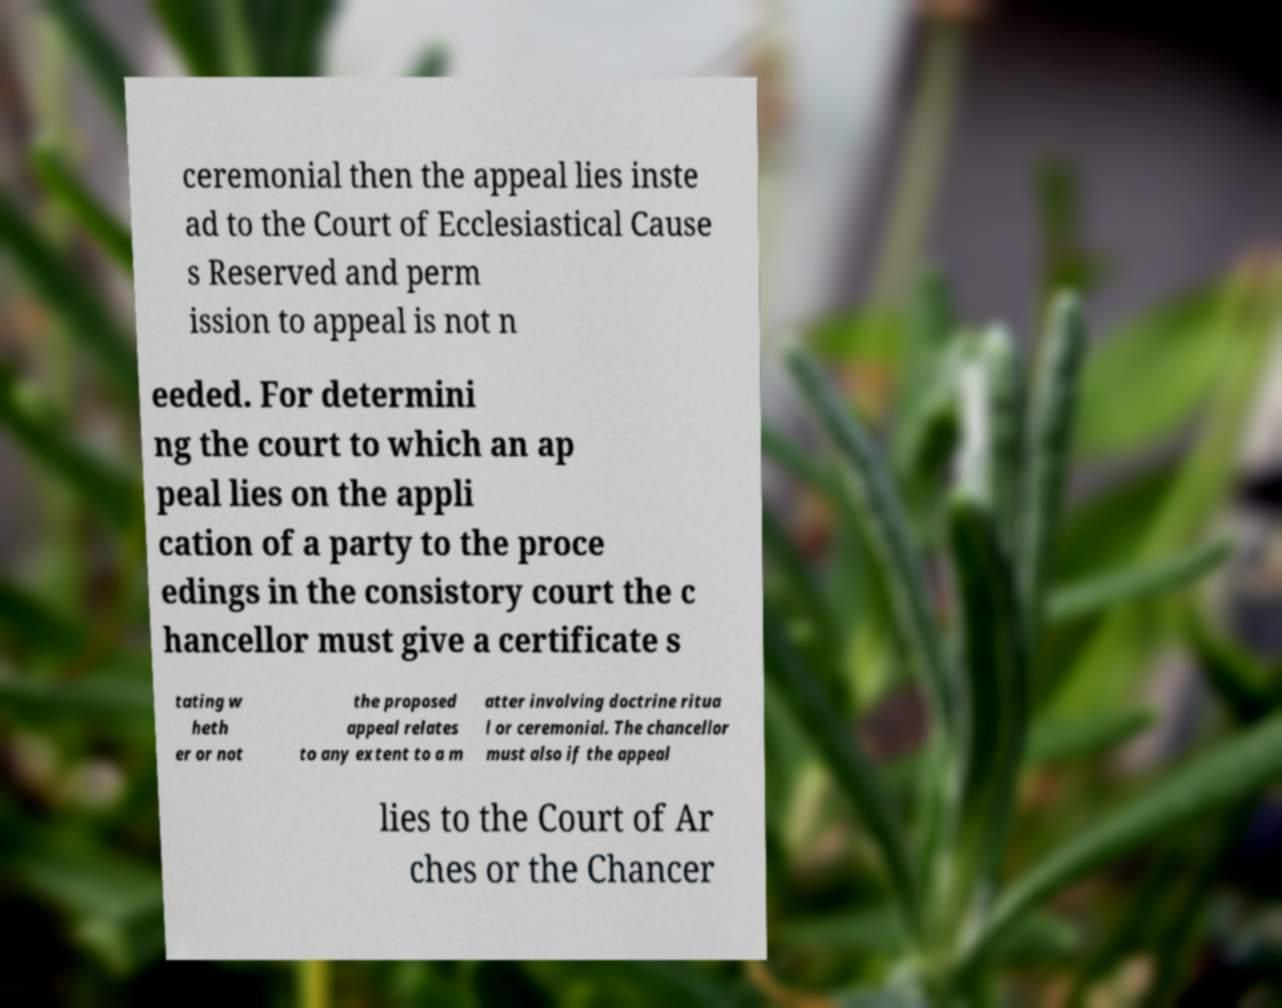Can you read and provide the text displayed in the image?This photo seems to have some interesting text. Can you extract and type it out for me? ceremonial then the appeal lies inste ad to the Court of Ecclesiastical Cause s Reserved and perm ission to appeal is not n eeded. For determini ng the court to which an ap peal lies on the appli cation of a party to the proce edings in the consistory court the c hancellor must give a certificate s tating w heth er or not the proposed appeal relates to any extent to a m atter involving doctrine ritua l or ceremonial. The chancellor must also if the appeal lies to the Court of Ar ches or the Chancer 